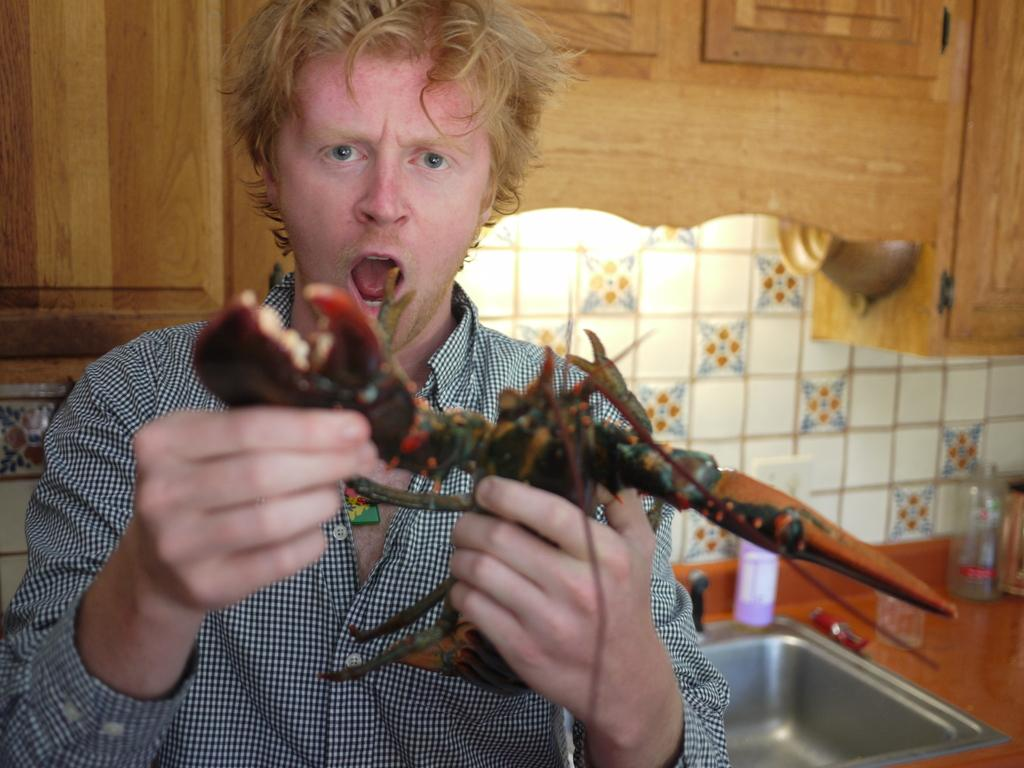What is the main subject of the image? There is a man in the image. What is the man holding in the image? The man is holding something. What can be seen in the background of the image? There is a wash basin, jars, a wall, a light, and a wooden cupboard in the background of the image. What type of picture is hanging on the wall in the image? There is no picture hanging on the wall in the image. Can you tell me what kind of vase is sitting on the wooden cupboard in the image? There is no vase present on the wooden cupboard in the image. 